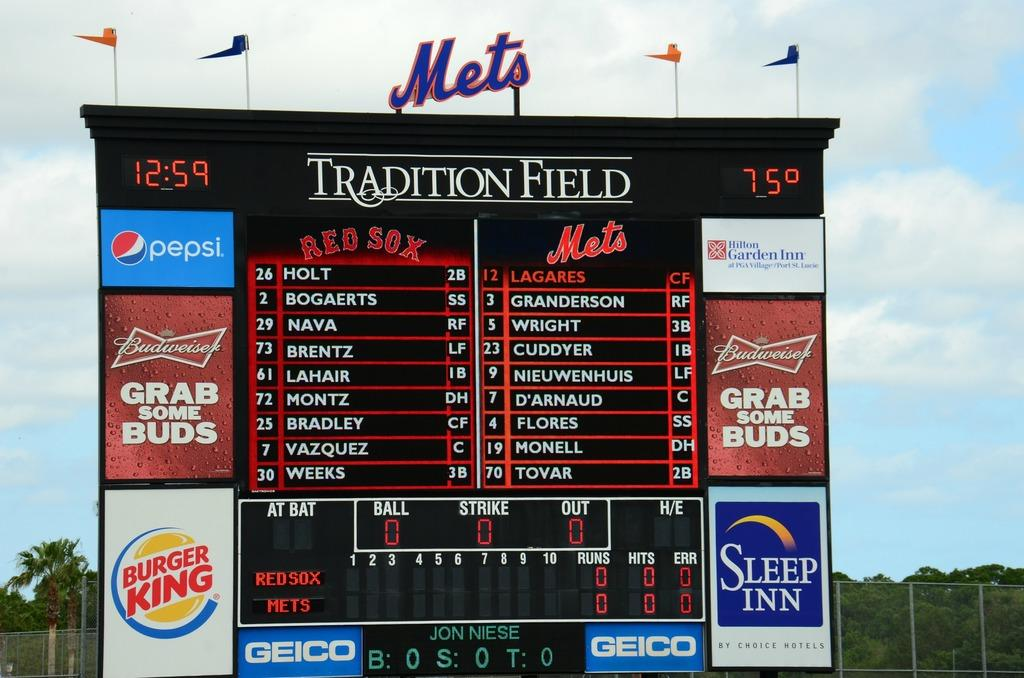<image>
Create a compact narrative representing the image presented. The sign at Tradition Field says that it is 75 degrees outside right now. 